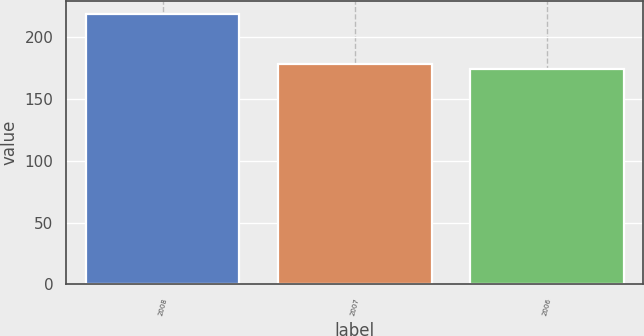Convert chart to OTSL. <chart><loc_0><loc_0><loc_500><loc_500><bar_chart><fcel>2008<fcel>2007<fcel>2006<nl><fcel>218<fcel>178.4<fcel>174<nl></chart> 